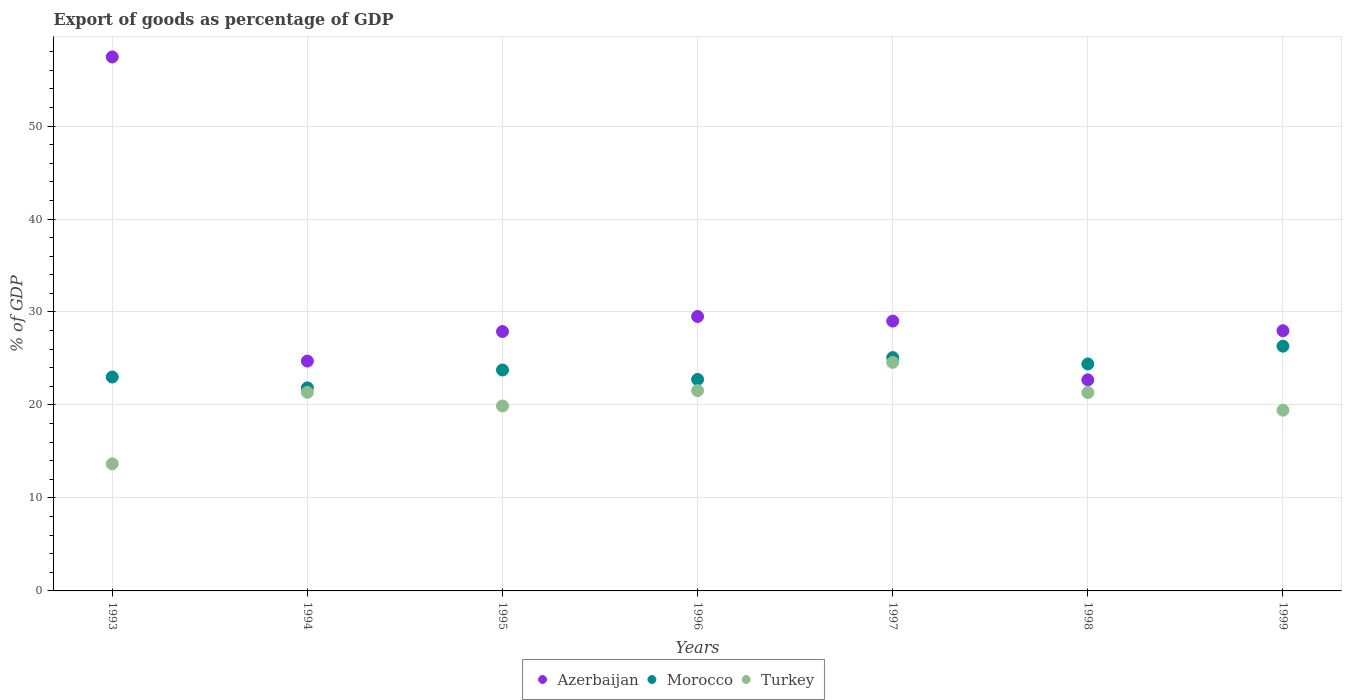Is the number of dotlines equal to the number of legend labels?
Ensure brevity in your answer.  Yes. What is the export of goods as percentage of GDP in Azerbaijan in 1996?
Offer a terse response. 29.52. Across all years, what is the maximum export of goods as percentage of GDP in Turkey?
Ensure brevity in your answer.  24.58. Across all years, what is the minimum export of goods as percentage of GDP in Turkey?
Make the answer very short. 13.67. In which year was the export of goods as percentage of GDP in Azerbaijan maximum?
Provide a succinct answer. 1993. In which year was the export of goods as percentage of GDP in Turkey minimum?
Make the answer very short. 1993. What is the total export of goods as percentage of GDP in Turkey in the graph?
Offer a terse response. 141.83. What is the difference between the export of goods as percentage of GDP in Turkey in 1998 and that in 1999?
Provide a succinct answer. 1.9. What is the difference between the export of goods as percentage of GDP in Morocco in 1997 and the export of goods as percentage of GDP in Turkey in 1996?
Offer a terse response. 3.55. What is the average export of goods as percentage of GDP in Turkey per year?
Offer a terse response. 20.26. In the year 1998, what is the difference between the export of goods as percentage of GDP in Morocco and export of goods as percentage of GDP in Turkey?
Offer a very short reply. 3.07. In how many years, is the export of goods as percentage of GDP in Morocco greater than 6 %?
Provide a short and direct response. 7. What is the ratio of the export of goods as percentage of GDP in Morocco in 1994 to that in 1995?
Ensure brevity in your answer.  0.92. Is the export of goods as percentage of GDP in Morocco in 1995 less than that in 1999?
Your answer should be compact. Yes. Is the difference between the export of goods as percentage of GDP in Morocco in 1993 and 1994 greater than the difference between the export of goods as percentage of GDP in Turkey in 1993 and 1994?
Make the answer very short. Yes. What is the difference between the highest and the second highest export of goods as percentage of GDP in Morocco?
Provide a succinct answer. 1.23. What is the difference between the highest and the lowest export of goods as percentage of GDP in Turkey?
Provide a short and direct response. 10.91. Does the export of goods as percentage of GDP in Morocco monotonically increase over the years?
Your answer should be very brief. No. Is the export of goods as percentage of GDP in Azerbaijan strictly greater than the export of goods as percentage of GDP in Turkey over the years?
Your answer should be compact. Yes. Is the export of goods as percentage of GDP in Turkey strictly less than the export of goods as percentage of GDP in Morocco over the years?
Your answer should be very brief. Yes. Where does the legend appear in the graph?
Offer a very short reply. Bottom center. How many legend labels are there?
Offer a terse response. 3. What is the title of the graph?
Your answer should be very brief. Export of goods as percentage of GDP. What is the label or title of the X-axis?
Your answer should be compact. Years. What is the label or title of the Y-axis?
Keep it short and to the point. % of GDP. What is the % of GDP of Azerbaijan in 1993?
Ensure brevity in your answer.  57.43. What is the % of GDP in Morocco in 1993?
Your answer should be compact. 23.01. What is the % of GDP of Turkey in 1993?
Provide a succinct answer. 13.67. What is the % of GDP in Azerbaijan in 1994?
Your answer should be very brief. 24.72. What is the % of GDP of Morocco in 1994?
Provide a succinct answer. 21.84. What is the % of GDP in Turkey in 1994?
Your answer should be compact. 21.36. What is the % of GDP in Azerbaijan in 1995?
Your response must be concise. 27.9. What is the % of GDP in Morocco in 1995?
Your answer should be very brief. 23.76. What is the % of GDP of Turkey in 1995?
Ensure brevity in your answer.  19.89. What is the % of GDP of Azerbaijan in 1996?
Provide a succinct answer. 29.52. What is the % of GDP in Morocco in 1996?
Ensure brevity in your answer.  22.75. What is the % of GDP of Turkey in 1996?
Your response must be concise. 21.54. What is the % of GDP of Azerbaijan in 1997?
Provide a succinct answer. 29.02. What is the % of GDP of Morocco in 1997?
Offer a very short reply. 25.1. What is the % of GDP of Turkey in 1997?
Make the answer very short. 24.58. What is the % of GDP of Azerbaijan in 1998?
Offer a very short reply. 22.7. What is the % of GDP of Morocco in 1998?
Make the answer very short. 24.41. What is the % of GDP of Turkey in 1998?
Keep it short and to the point. 21.34. What is the % of GDP of Azerbaijan in 1999?
Ensure brevity in your answer.  27.98. What is the % of GDP of Morocco in 1999?
Offer a very short reply. 26.32. What is the % of GDP of Turkey in 1999?
Your response must be concise. 19.44. Across all years, what is the maximum % of GDP in Azerbaijan?
Ensure brevity in your answer.  57.43. Across all years, what is the maximum % of GDP in Morocco?
Keep it short and to the point. 26.32. Across all years, what is the maximum % of GDP in Turkey?
Your answer should be very brief. 24.58. Across all years, what is the minimum % of GDP in Azerbaijan?
Your answer should be compact. 22.7. Across all years, what is the minimum % of GDP of Morocco?
Offer a terse response. 21.84. Across all years, what is the minimum % of GDP in Turkey?
Make the answer very short. 13.67. What is the total % of GDP of Azerbaijan in the graph?
Your response must be concise. 219.28. What is the total % of GDP of Morocco in the graph?
Provide a short and direct response. 167.18. What is the total % of GDP of Turkey in the graph?
Provide a succinct answer. 141.83. What is the difference between the % of GDP of Azerbaijan in 1993 and that in 1994?
Offer a very short reply. 32.71. What is the difference between the % of GDP in Morocco in 1993 and that in 1994?
Make the answer very short. 1.17. What is the difference between the % of GDP in Turkey in 1993 and that in 1994?
Provide a short and direct response. -7.69. What is the difference between the % of GDP in Azerbaijan in 1993 and that in 1995?
Offer a terse response. 29.53. What is the difference between the % of GDP in Morocco in 1993 and that in 1995?
Keep it short and to the point. -0.76. What is the difference between the % of GDP in Turkey in 1993 and that in 1995?
Ensure brevity in your answer.  -6.22. What is the difference between the % of GDP in Azerbaijan in 1993 and that in 1996?
Provide a short and direct response. 27.92. What is the difference between the % of GDP in Morocco in 1993 and that in 1996?
Provide a short and direct response. 0.26. What is the difference between the % of GDP in Turkey in 1993 and that in 1996?
Provide a short and direct response. -7.87. What is the difference between the % of GDP of Azerbaijan in 1993 and that in 1997?
Your response must be concise. 28.41. What is the difference between the % of GDP of Morocco in 1993 and that in 1997?
Give a very brief answer. -2.09. What is the difference between the % of GDP of Turkey in 1993 and that in 1997?
Ensure brevity in your answer.  -10.91. What is the difference between the % of GDP of Azerbaijan in 1993 and that in 1998?
Offer a terse response. 34.73. What is the difference between the % of GDP of Morocco in 1993 and that in 1998?
Ensure brevity in your answer.  -1.41. What is the difference between the % of GDP in Turkey in 1993 and that in 1998?
Ensure brevity in your answer.  -7.66. What is the difference between the % of GDP in Azerbaijan in 1993 and that in 1999?
Your answer should be compact. 29.45. What is the difference between the % of GDP in Morocco in 1993 and that in 1999?
Offer a terse response. -3.32. What is the difference between the % of GDP of Turkey in 1993 and that in 1999?
Ensure brevity in your answer.  -5.77. What is the difference between the % of GDP in Azerbaijan in 1994 and that in 1995?
Offer a very short reply. -3.18. What is the difference between the % of GDP in Morocco in 1994 and that in 1995?
Provide a succinct answer. -1.92. What is the difference between the % of GDP in Turkey in 1994 and that in 1995?
Provide a succinct answer. 1.47. What is the difference between the % of GDP of Azerbaijan in 1994 and that in 1996?
Your response must be concise. -4.79. What is the difference between the % of GDP of Morocco in 1994 and that in 1996?
Your response must be concise. -0.91. What is the difference between the % of GDP of Turkey in 1994 and that in 1996?
Keep it short and to the point. -0.18. What is the difference between the % of GDP of Azerbaijan in 1994 and that in 1997?
Provide a short and direct response. -4.3. What is the difference between the % of GDP in Morocco in 1994 and that in 1997?
Offer a terse response. -3.26. What is the difference between the % of GDP in Turkey in 1994 and that in 1997?
Provide a succinct answer. -3.22. What is the difference between the % of GDP of Azerbaijan in 1994 and that in 1998?
Make the answer very short. 2.02. What is the difference between the % of GDP of Morocco in 1994 and that in 1998?
Provide a succinct answer. -2.57. What is the difference between the % of GDP in Turkey in 1994 and that in 1998?
Offer a terse response. 0.02. What is the difference between the % of GDP of Azerbaijan in 1994 and that in 1999?
Keep it short and to the point. -3.26. What is the difference between the % of GDP in Morocco in 1994 and that in 1999?
Offer a very short reply. -4.48. What is the difference between the % of GDP in Turkey in 1994 and that in 1999?
Offer a very short reply. 1.92. What is the difference between the % of GDP in Azerbaijan in 1995 and that in 1996?
Provide a succinct answer. -1.61. What is the difference between the % of GDP in Morocco in 1995 and that in 1996?
Provide a succinct answer. 1.02. What is the difference between the % of GDP in Turkey in 1995 and that in 1996?
Offer a terse response. -1.65. What is the difference between the % of GDP of Azerbaijan in 1995 and that in 1997?
Provide a short and direct response. -1.12. What is the difference between the % of GDP in Morocco in 1995 and that in 1997?
Offer a terse response. -1.33. What is the difference between the % of GDP of Turkey in 1995 and that in 1997?
Your answer should be very brief. -4.69. What is the difference between the % of GDP of Azerbaijan in 1995 and that in 1998?
Offer a very short reply. 5.2. What is the difference between the % of GDP in Morocco in 1995 and that in 1998?
Your answer should be compact. -0.65. What is the difference between the % of GDP of Turkey in 1995 and that in 1998?
Make the answer very short. -1.45. What is the difference between the % of GDP in Azerbaijan in 1995 and that in 1999?
Provide a succinct answer. -0.08. What is the difference between the % of GDP in Morocco in 1995 and that in 1999?
Keep it short and to the point. -2.56. What is the difference between the % of GDP in Turkey in 1995 and that in 1999?
Provide a short and direct response. 0.45. What is the difference between the % of GDP in Azerbaijan in 1996 and that in 1997?
Your response must be concise. 0.49. What is the difference between the % of GDP of Morocco in 1996 and that in 1997?
Ensure brevity in your answer.  -2.35. What is the difference between the % of GDP of Turkey in 1996 and that in 1997?
Keep it short and to the point. -3.04. What is the difference between the % of GDP of Azerbaijan in 1996 and that in 1998?
Make the answer very short. 6.81. What is the difference between the % of GDP in Morocco in 1996 and that in 1998?
Keep it short and to the point. -1.67. What is the difference between the % of GDP of Turkey in 1996 and that in 1998?
Your response must be concise. 0.2. What is the difference between the % of GDP of Azerbaijan in 1996 and that in 1999?
Keep it short and to the point. 1.53. What is the difference between the % of GDP of Morocco in 1996 and that in 1999?
Ensure brevity in your answer.  -3.58. What is the difference between the % of GDP in Turkey in 1996 and that in 1999?
Your answer should be very brief. 2.1. What is the difference between the % of GDP in Azerbaijan in 1997 and that in 1998?
Your response must be concise. 6.32. What is the difference between the % of GDP of Morocco in 1997 and that in 1998?
Your response must be concise. 0.68. What is the difference between the % of GDP in Turkey in 1997 and that in 1998?
Your response must be concise. 3.24. What is the difference between the % of GDP in Azerbaijan in 1997 and that in 1999?
Make the answer very short. 1.04. What is the difference between the % of GDP in Morocco in 1997 and that in 1999?
Provide a short and direct response. -1.23. What is the difference between the % of GDP in Turkey in 1997 and that in 1999?
Keep it short and to the point. 5.14. What is the difference between the % of GDP in Azerbaijan in 1998 and that in 1999?
Provide a short and direct response. -5.28. What is the difference between the % of GDP of Morocco in 1998 and that in 1999?
Offer a very short reply. -1.91. What is the difference between the % of GDP in Turkey in 1998 and that in 1999?
Your answer should be very brief. 1.9. What is the difference between the % of GDP in Azerbaijan in 1993 and the % of GDP in Morocco in 1994?
Ensure brevity in your answer.  35.59. What is the difference between the % of GDP in Azerbaijan in 1993 and the % of GDP in Turkey in 1994?
Provide a short and direct response. 36.07. What is the difference between the % of GDP in Morocco in 1993 and the % of GDP in Turkey in 1994?
Your answer should be very brief. 1.64. What is the difference between the % of GDP in Azerbaijan in 1993 and the % of GDP in Morocco in 1995?
Your response must be concise. 33.67. What is the difference between the % of GDP of Azerbaijan in 1993 and the % of GDP of Turkey in 1995?
Provide a short and direct response. 37.54. What is the difference between the % of GDP in Morocco in 1993 and the % of GDP in Turkey in 1995?
Offer a very short reply. 3.11. What is the difference between the % of GDP in Azerbaijan in 1993 and the % of GDP in Morocco in 1996?
Your answer should be compact. 34.69. What is the difference between the % of GDP in Azerbaijan in 1993 and the % of GDP in Turkey in 1996?
Provide a short and direct response. 35.89. What is the difference between the % of GDP in Morocco in 1993 and the % of GDP in Turkey in 1996?
Your answer should be compact. 1.46. What is the difference between the % of GDP of Azerbaijan in 1993 and the % of GDP of Morocco in 1997?
Your answer should be very brief. 32.34. What is the difference between the % of GDP of Azerbaijan in 1993 and the % of GDP of Turkey in 1997?
Your answer should be very brief. 32.85. What is the difference between the % of GDP of Morocco in 1993 and the % of GDP of Turkey in 1997?
Give a very brief answer. -1.58. What is the difference between the % of GDP in Azerbaijan in 1993 and the % of GDP in Morocco in 1998?
Your answer should be very brief. 33.02. What is the difference between the % of GDP in Azerbaijan in 1993 and the % of GDP in Turkey in 1998?
Offer a terse response. 36.09. What is the difference between the % of GDP of Morocco in 1993 and the % of GDP of Turkey in 1998?
Offer a very short reply. 1.67. What is the difference between the % of GDP of Azerbaijan in 1993 and the % of GDP of Morocco in 1999?
Offer a very short reply. 31.11. What is the difference between the % of GDP in Azerbaijan in 1993 and the % of GDP in Turkey in 1999?
Provide a succinct answer. 37.99. What is the difference between the % of GDP in Morocco in 1993 and the % of GDP in Turkey in 1999?
Keep it short and to the point. 3.57. What is the difference between the % of GDP of Azerbaijan in 1994 and the % of GDP of Morocco in 1995?
Keep it short and to the point. 0.96. What is the difference between the % of GDP of Azerbaijan in 1994 and the % of GDP of Turkey in 1995?
Your response must be concise. 4.83. What is the difference between the % of GDP in Morocco in 1994 and the % of GDP in Turkey in 1995?
Your response must be concise. 1.95. What is the difference between the % of GDP in Azerbaijan in 1994 and the % of GDP in Morocco in 1996?
Your answer should be compact. 1.98. What is the difference between the % of GDP in Azerbaijan in 1994 and the % of GDP in Turkey in 1996?
Provide a short and direct response. 3.18. What is the difference between the % of GDP of Morocco in 1994 and the % of GDP of Turkey in 1996?
Make the answer very short. 0.3. What is the difference between the % of GDP in Azerbaijan in 1994 and the % of GDP in Morocco in 1997?
Ensure brevity in your answer.  -0.37. What is the difference between the % of GDP of Azerbaijan in 1994 and the % of GDP of Turkey in 1997?
Provide a short and direct response. 0.14. What is the difference between the % of GDP of Morocco in 1994 and the % of GDP of Turkey in 1997?
Make the answer very short. -2.74. What is the difference between the % of GDP of Azerbaijan in 1994 and the % of GDP of Morocco in 1998?
Your response must be concise. 0.31. What is the difference between the % of GDP in Azerbaijan in 1994 and the % of GDP in Turkey in 1998?
Your answer should be compact. 3.38. What is the difference between the % of GDP of Morocco in 1994 and the % of GDP of Turkey in 1998?
Ensure brevity in your answer.  0.5. What is the difference between the % of GDP in Azerbaijan in 1994 and the % of GDP in Morocco in 1999?
Your answer should be compact. -1.6. What is the difference between the % of GDP in Azerbaijan in 1994 and the % of GDP in Turkey in 1999?
Offer a terse response. 5.28. What is the difference between the % of GDP of Morocco in 1994 and the % of GDP of Turkey in 1999?
Offer a very short reply. 2.4. What is the difference between the % of GDP in Azerbaijan in 1995 and the % of GDP in Morocco in 1996?
Ensure brevity in your answer.  5.15. What is the difference between the % of GDP of Azerbaijan in 1995 and the % of GDP of Turkey in 1996?
Provide a short and direct response. 6.36. What is the difference between the % of GDP of Morocco in 1995 and the % of GDP of Turkey in 1996?
Your answer should be compact. 2.22. What is the difference between the % of GDP in Azerbaijan in 1995 and the % of GDP in Morocco in 1997?
Offer a very short reply. 2.81. What is the difference between the % of GDP in Azerbaijan in 1995 and the % of GDP in Turkey in 1997?
Offer a terse response. 3.32. What is the difference between the % of GDP of Morocco in 1995 and the % of GDP of Turkey in 1997?
Your response must be concise. -0.82. What is the difference between the % of GDP in Azerbaijan in 1995 and the % of GDP in Morocco in 1998?
Your answer should be very brief. 3.49. What is the difference between the % of GDP of Azerbaijan in 1995 and the % of GDP of Turkey in 1998?
Your answer should be very brief. 6.56. What is the difference between the % of GDP of Morocco in 1995 and the % of GDP of Turkey in 1998?
Give a very brief answer. 2.43. What is the difference between the % of GDP of Azerbaijan in 1995 and the % of GDP of Morocco in 1999?
Offer a terse response. 1.58. What is the difference between the % of GDP of Azerbaijan in 1995 and the % of GDP of Turkey in 1999?
Provide a short and direct response. 8.46. What is the difference between the % of GDP in Morocco in 1995 and the % of GDP in Turkey in 1999?
Your answer should be compact. 4.32. What is the difference between the % of GDP of Azerbaijan in 1996 and the % of GDP of Morocco in 1997?
Give a very brief answer. 4.42. What is the difference between the % of GDP of Azerbaijan in 1996 and the % of GDP of Turkey in 1997?
Give a very brief answer. 4.93. What is the difference between the % of GDP of Morocco in 1996 and the % of GDP of Turkey in 1997?
Offer a very short reply. -1.83. What is the difference between the % of GDP in Azerbaijan in 1996 and the % of GDP in Morocco in 1998?
Ensure brevity in your answer.  5.1. What is the difference between the % of GDP of Azerbaijan in 1996 and the % of GDP of Turkey in 1998?
Your answer should be very brief. 8.18. What is the difference between the % of GDP of Morocco in 1996 and the % of GDP of Turkey in 1998?
Your answer should be very brief. 1.41. What is the difference between the % of GDP of Azerbaijan in 1996 and the % of GDP of Morocco in 1999?
Keep it short and to the point. 3.19. What is the difference between the % of GDP in Azerbaijan in 1996 and the % of GDP in Turkey in 1999?
Make the answer very short. 10.08. What is the difference between the % of GDP in Morocco in 1996 and the % of GDP in Turkey in 1999?
Give a very brief answer. 3.31. What is the difference between the % of GDP of Azerbaijan in 1997 and the % of GDP of Morocco in 1998?
Offer a very short reply. 4.61. What is the difference between the % of GDP of Azerbaijan in 1997 and the % of GDP of Turkey in 1998?
Offer a very short reply. 7.68. What is the difference between the % of GDP of Morocco in 1997 and the % of GDP of Turkey in 1998?
Keep it short and to the point. 3.76. What is the difference between the % of GDP in Azerbaijan in 1997 and the % of GDP in Morocco in 1999?
Provide a succinct answer. 2.7. What is the difference between the % of GDP of Azerbaijan in 1997 and the % of GDP of Turkey in 1999?
Give a very brief answer. 9.58. What is the difference between the % of GDP of Morocco in 1997 and the % of GDP of Turkey in 1999?
Your answer should be very brief. 5.66. What is the difference between the % of GDP in Azerbaijan in 1998 and the % of GDP in Morocco in 1999?
Offer a terse response. -3.62. What is the difference between the % of GDP in Azerbaijan in 1998 and the % of GDP in Turkey in 1999?
Give a very brief answer. 3.26. What is the difference between the % of GDP in Morocco in 1998 and the % of GDP in Turkey in 1999?
Provide a short and direct response. 4.97. What is the average % of GDP of Azerbaijan per year?
Offer a terse response. 31.33. What is the average % of GDP in Morocco per year?
Make the answer very short. 23.88. What is the average % of GDP in Turkey per year?
Keep it short and to the point. 20.26. In the year 1993, what is the difference between the % of GDP in Azerbaijan and % of GDP in Morocco?
Your answer should be compact. 34.43. In the year 1993, what is the difference between the % of GDP in Azerbaijan and % of GDP in Turkey?
Provide a succinct answer. 43.76. In the year 1993, what is the difference between the % of GDP of Morocco and % of GDP of Turkey?
Your answer should be compact. 9.33. In the year 1994, what is the difference between the % of GDP in Azerbaijan and % of GDP in Morocco?
Your answer should be very brief. 2.88. In the year 1994, what is the difference between the % of GDP in Azerbaijan and % of GDP in Turkey?
Your response must be concise. 3.36. In the year 1994, what is the difference between the % of GDP of Morocco and % of GDP of Turkey?
Your answer should be very brief. 0.48. In the year 1995, what is the difference between the % of GDP of Azerbaijan and % of GDP of Morocco?
Your answer should be compact. 4.14. In the year 1995, what is the difference between the % of GDP of Azerbaijan and % of GDP of Turkey?
Provide a short and direct response. 8.01. In the year 1995, what is the difference between the % of GDP of Morocco and % of GDP of Turkey?
Ensure brevity in your answer.  3.87. In the year 1996, what is the difference between the % of GDP of Azerbaijan and % of GDP of Morocco?
Ensure brevity in your answer.  6.77. In the year 1996, what is the difference between the % of GDP of Azerbaijan and % of GDP of Turkey?
Offer a terse response. 7.97. In the year 1996, what is the difference between the % of GDP in Morocco and % of GDP in Turkey?
Give a very brief answer. 1.2. In the year 1997, what is the difference between the % of GDP in Azerbaijan and % of GDP in Morocco?
Provide a short and direct response. 3.93. In the year 1997, what is the difference between the % of GDP of Azerbaijan and % of GDP of Turkey?
Your answer should be very brief. 4.44. In the year 1997, what is the difference between the % of GDP of Morocco and % of GDP of Turkey?
Provide a succinct answer. 0.51. In the year 1998, what is the difference between the % of GDP of Azerbaijan and % of GDP of Morocco?
Ensure brevity in your answer.  -1.71. In the year 1998, what is the difference between the % of GDP of Azerbaijan and % of GDP of Turkey?
Offer a very short reply. 1.36. In the year 1998, what is the difference between the % of GDP of Morocco and % of GDP of Turkey?
Offer a terse response. 3.07. In the year 1999, what is the difference between the % of GDP of Azerbaijan and % of GDP of Morocco?
Offer a terse response. 1.66. In the year 1999, what is the difference between the % of GDP of Azerbaijan and % of GDP of Turkey?
Provide a succinct answer. 8.54. In the year 1999, what is the difference between the % of GDP in Morocco and % of GDP in Turkey?
Your response must be concise. 6.88. What is the ratio of the % of GDP of Azerbaijan in 1993 to that in 1994?
Ensure brevity in your answer.  2.32. What is the ratio of the % of GDP in Morocco in 1993 to that in 1994?
Keep it short and to the point. 1.05. What is the ratio of the % of GDP in Turkey in 1993 to that in 1994?
Make the answer very short. 0.64. What is the ratio of the % of GDP of Azerbaijan in 1993 to that in 1995?
Give a very brief answer. 2.06. What is the ratio of the % of GDP in Morocco in 1993 to that in 1995?
Your answer should be compact. 0.97. What is the ratio of the % of GDP in Turkey in 1993 to that in 1995?
Your answer should be very brief. 0.69. What is the ratio of the % of GDP of Azerbaijan in 1993 to that in 1996?
Make the answer very short. 1.95. What is the ratio of the % of GDP of Morocco in 1993 to that in 1996?
Your answer should be compact. 1.01. What is the ratio of the % of GDP of Turkey in 1993 to that in 1996?
Your response must be concise. 0.63. What is the ratio of the % of GDP in Azerbaijan in 1993 to that in 1997?
Give a very brief answer. 1.98. What is the ratio of the % of GDP in Morocco in 1993 to that in 1997?
Provide a short and direct response. 0.92. What is the ratio of the % of GDP in Turkey in 1993 to that in 1997?
Make the answer very short. 0.56. What is the ratio of the % of GDP in Azerbaijan in 1993 to that in 1998?
Make the answer very short. 2.53. What is the ratio of the % of GDP of Morocco in 1993 to that in 1998?
Provide a short and direct response. 0.94. What is the ratio of the % of GDP in Turkey in 1993 to that in 1998?
Your answer should be compact. 0.64. What is the ratio of the % of GDP in Azerbaijan in 1993 to that in 1999?
Your answer should be compact. 2.05. What is the ratio of the % of GDP in Morocco in 1993 to that in 1999?
Keep it short and to the point. 0.87. What is the ratio of the % of GDP of Turkey in 1993 to that in 1999?
Make the answer very short. 0.7. What is the ratio of the % of GDP of Azerbaijan in 1994 to that in 1995?
Make the answer very short. 0.89. What is the ratio of the % of GDP of Morocco in 1994 to that in 1995?
Your answer should be compact. 0.92. What is the ratio of the % of GDP in Turkey in 1994 to that in 1995?
Ensure brevity in your answer.  1.07. What is the ratio of the % of GDP of Azerbaijan in 1994 to that in 1996?
Your response must be concise. 0.84. What is the ratio of the % of GDP of Morocco in 1994 to that in 1996?
Provide a succinct answer. 0.96. What is the ratio of the % of GDP of Azerbaijan in 1994 to that in 1997?
Ensure brevity in your answer.  0.85. What is the ratio of the % of GDP in Morocco in 1994 to that in 1997?
Provide a short and direct response. 0.87. What is the ratio of the % of GDP of Turkey in 1994 to that in 1997?
Keep it short and to the point. 0.87. What is the ratio of the % of GDP in Azerbaijan in 1994 to that in 1998?
Offer a terse response. 1.09. What is the ratio of the % of GDP of Morocco in 1994 to that in 1998?
Keep it short and to the point. 0.89. What is the ratio of the % of GDP of Azerbaijan in 1994 to that in 1999?
Keep it short and to the point. 0.88. What is the ratio of the % of GDP of Morocco in 1994 to that in 1999?
Make the answer very short. 0.83. What is the ratio of the % of GDP in Turkey in 1994 to that in 1999?
Your response must be concise. 1.1. What is the ratio of the % of GDP in Azerbaijan in 1995 to that in 1996?
Your answer should be compact. 0.95. What is the ratio of the % of GDP in Morocco in 1995 to that in 1996?
Provide a short and direct response. 1.04. What is the ratio of the % of GDP of Turkey in 1995 to that in 1996?
Offer a very short reply. 0.92. What is the ratio of the % of GDP in Azerbaijan in 1995 to that in 1997?
Provide a short and direct response. 0.96. What is the ratio of the % of GDP in Morocco in 1995 to that in 1997?
Your answer should be very brief. 0.95. What is the ratio of the % of GDP of Turkey in 1995 to that in 1997?
Make the answer very short. 0.81. What is the ratio of the % of GDP of Azerbaijan in 1995 to that in 1998?
Give a very brief answer. 1.23. What is the ratio of the % of GDP of Morocco in 1995 to that in 1998?
Your answer should be very brief. 0.97. What is the ratio of the % of GDP in Turkey in 1995 to that in 1998?
Your answer should be compact. 0.93. What is the ratio of the % of GDP of Morocco in 1995 to that in 1999?
Your response must be concise. 0.9. What is the ratio of the % of GDP of Turkey in 1995 to that in 1999?
Provide a succinct answer. 1.02. What is the ratio of the % of GDP in Morocco in 1996 to that in 1997?
Offer a terse response. 0.91. What is the ratio of the % of GDP of Turkey in 1996 to that in 1997?
Give a very brief answer. 0.88. What is the ratio of the % of GDP in Azerbaijan in 1996 to that in 1998?
Provide a short and direct response. 1.3. What is the ratio of the % of GDP of Morocco in 1996 to that in 1998?
Your answer should be compact. 0.93. What is the ratio of the % of GDP of Turkey in 1996 to that in 1998?
Offer a terse response. 1.01. What is the ratio of the % of GDP of Azerbaijan in 1996 to that in 1999?
Ensure brevity in your answer.  1.05. What is the ratio of the % of GDP in Morocco in 1996 to that in 1999?
Provide a succinct answer. 0.86. What is the ratio of the % of GDP in Turkey in 1996 to that in 1999?
Make the answer very short. 1.11. What is the ratio of the % of GDP of Azerbaijan in 1997 to that in 1998?
Offer a very short reply. 1.28. What is the ratio of the % of GDP in Morocco in 1997 to that in 1998?
Offer a terse response. 1.03. What is the ratio of the % of GDP in Turkey in 1997 to that in 1998?
Your answer should be compact. 1.15. What is the ratio of the % of GDP of Azerbaijan in 1997 to that in 1999?
Your response must be concise. 1.04. What is the ratio of the % of GDP of Morocco in 1997 to that in 1999?
Make the answer very short. 0.95. What is the ratio of the % of GDP in Turkey in 1997 to that in 1999?
Your answer should be very brief. 1.26. What is the ratio of the % of GDP of Azerbaijan in 1998 to that in 1999?
Provide a succinct answer. 0.81. What is the ratio of the % of GDP of Morocco in 1998 to that in 1999?
Give a very brief answer. 0.93. What is the ratio of the % of GDP in Turkey in 1998 to that in 1999?
Provide a succinct answer. 1.1. What is the difference between the highest and the second highest % of GDP of Azerbaijan?
Give a very brief answer. 27.92. What is the difference between the highest and the second highest % of GDP of Morocco?
Provide a short and direct response. 1.23. What is the difference between the highest and the second highest % of GDP in Turkey?
Give a very brief answer. 3.04. What is the difference between the highest and the lowest % of GDP of Azerbaijan?
Your answer should be compact. 34.73. What is the difference between the highest and the lowest % of GDP of Morocco?
Keep it short and to the point. 4.48. What is the difference between the highest and the lowest % of GDP in Turkey?
Your answer should be very brief. 10.91. 